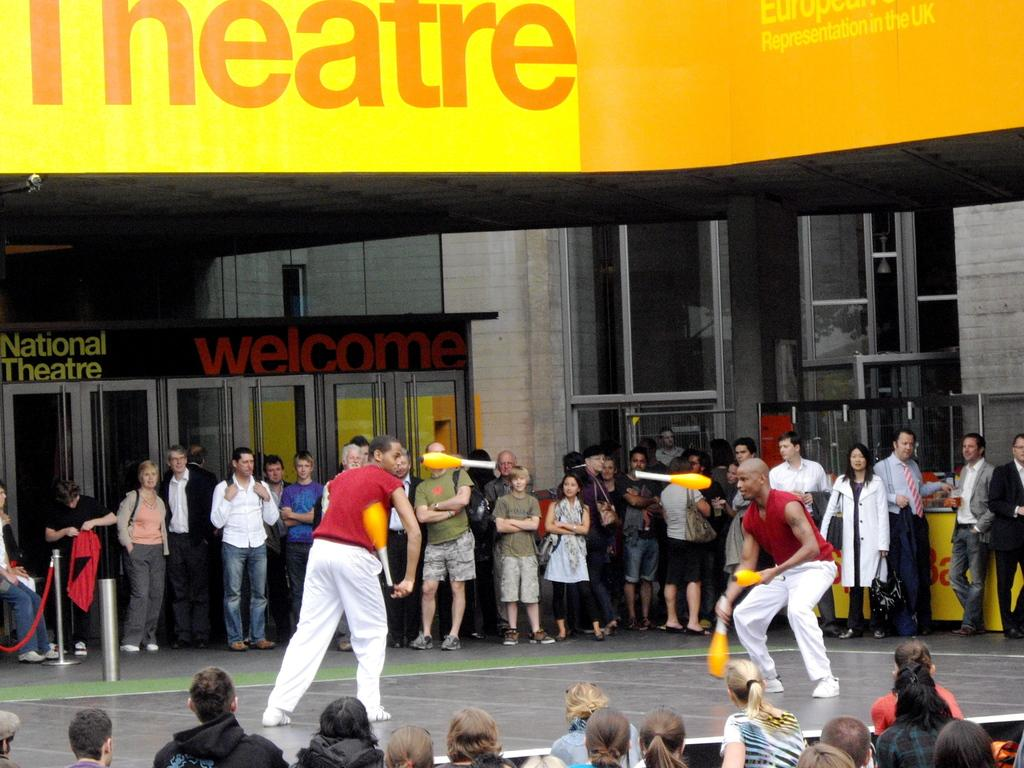How many people are in the image? There are two persons in the image. What are the two persons wearing? Both persons are wearing red dresses. What are the two persons doing in the image? They are standing and playing with a yellow object. Are there any other people in the image? Yes, there are people standing on either side of them. What type of eggs can be seen in the image? There are no eggs present in the image. How many dresses are visible in the image? There are two dresses visible in the image, as both persons are wearing red dresses. 